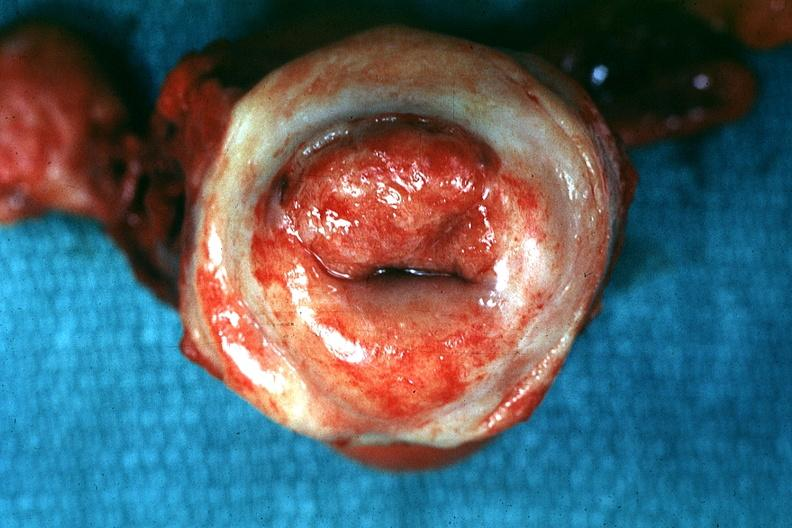does krukenberg tumor show excellent close-up of thickened?
Answer the question using a single word or phrase. No 